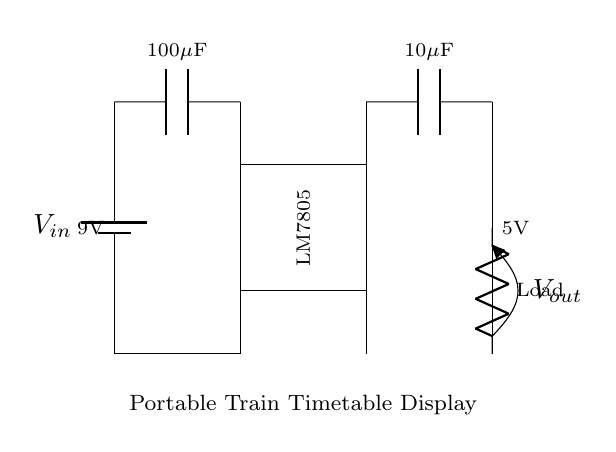What is the input voltage of the circuit? The input voltage is labeled as 9V, denoting the voltage supplied to the regulator to drop it down to the output voltage.
Answer: 9V What is the output voltage of the regulator? The output voltage, indicated as 5V, is the voltage delivered to the load after regulation from the input voltage.
Answer: 5V How many capacitors are present in the circuit? There are two capacitors: one with a value of 100 microfarads connected to the input and another with a value of 10 microfarads at the output.
Answer: 2 What is the function of the LM7805 in the circuit? The LM7805 is a voltage regulator that converts the input voltage to a stable 5V output, providing the necessary power for the portable train timetable display.
Answer: Voltage regulator What is the load connected in this circuit? The load is labeled simply as "Load" in the diagram, indicating the portable train timetable display powered by the circuit.
Answer: Portable train timetable display Why is an input capacitor necessary for this circuit? The input capacitor stabilizes the voltage level from the battery by smoothing fluctuations, which helps to maintain a steady voltage for the regulator's operation.
Answer: Stabilization What happens to the input voltage across the voltage regulator? The input voltage drops from 9V to 5V after passing through the voltage regulator, which is designed to provide a lower and stable voltage to the load.
Answer: It drops 